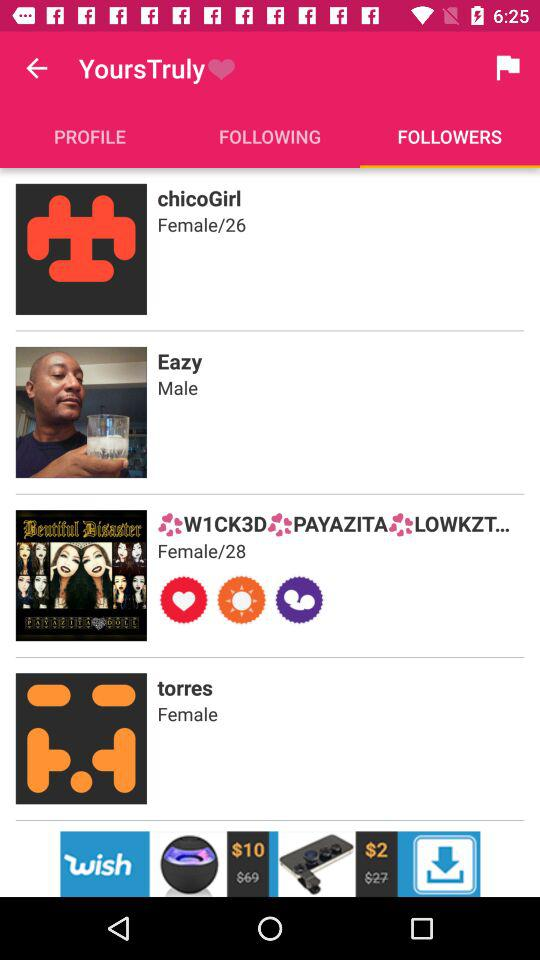Which tab is currently selected? The currently selected tab is "FOLLOWERS". 